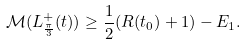Convert formula to latex. <formula><loc_0><loc_0><loc_500><loc_500>\mathcal { M } ( L ^ { + } _ { \frac { \pi } { 3 } } ( t ) ) \geq \frac { 1 } { 2 } ( R ( t _ { 0 } ) + 1 ) - E _ { 1 } .</formula> 